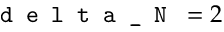<formula> <loc_0><loc_0><loc_500><loc_500>d e l t a \_ N = 2</formula> 